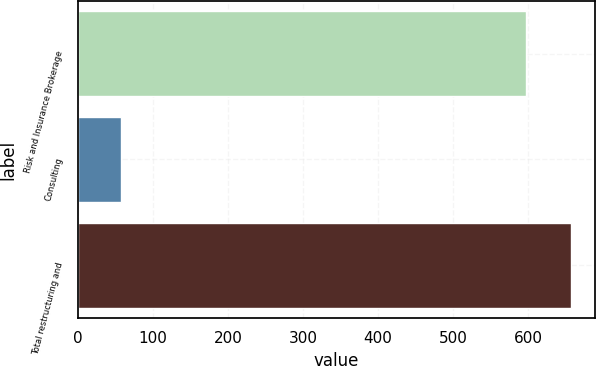Convert chart to OTSL. <chart><loc_0><loc_0><loc_500><loc_500><bar_chart><fcel>Risk and Insurance Brokerage<fcel>Consulting<fcel>Total restructuring and<nl><fcel>597<fcel>57<fcel>656.7<nl></chart> 